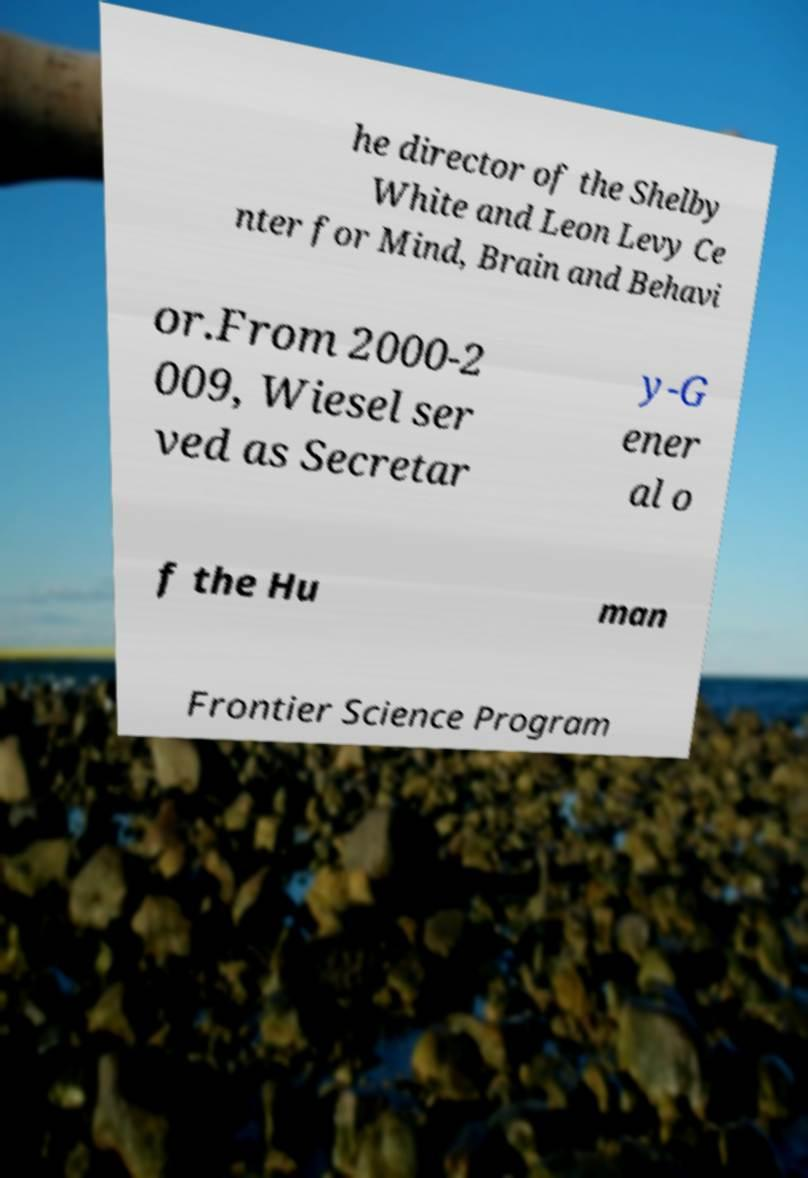For documentation purposes, I need the text within this image transcribed. Could you provide that? he director of the Shelby White and Leon Levy Ce nter for Mind, Brain and Behavi or.From 2000-2 009, Wiesel ser ved as Secretar y-G ener al o f the Hu man Frontier Science Program 